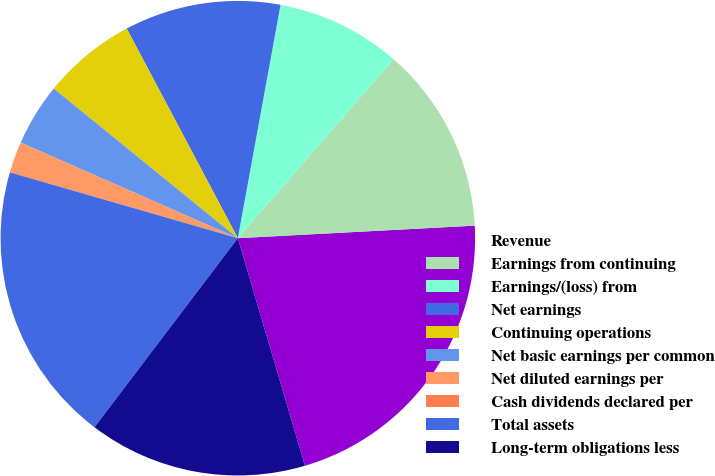Convert chart to OTSL. <chart><loc_0><loc_0><loc_500><loc_500><pie_chart><fcel>Revenue<fcel>Earnings from continuing<fcel>Earnings/(loss) from<fcel>Net earnings<fcel>Continuing operations<fcel>Net basic earnings per common<fcel>Net diluted earnings per<fcel>Cash dividends declared per<fcel>Total assets<fcel>Long-term obligations less<nl><fcel>21.28%<fcel>12.77%<fcel>8.51%<fcel>10.64%<fcel>6.38%<fcel>4.26%<fcel>2.13%<fcel>0.0%<fcel>19.15%<fcel>14.89%<nl></chart> 